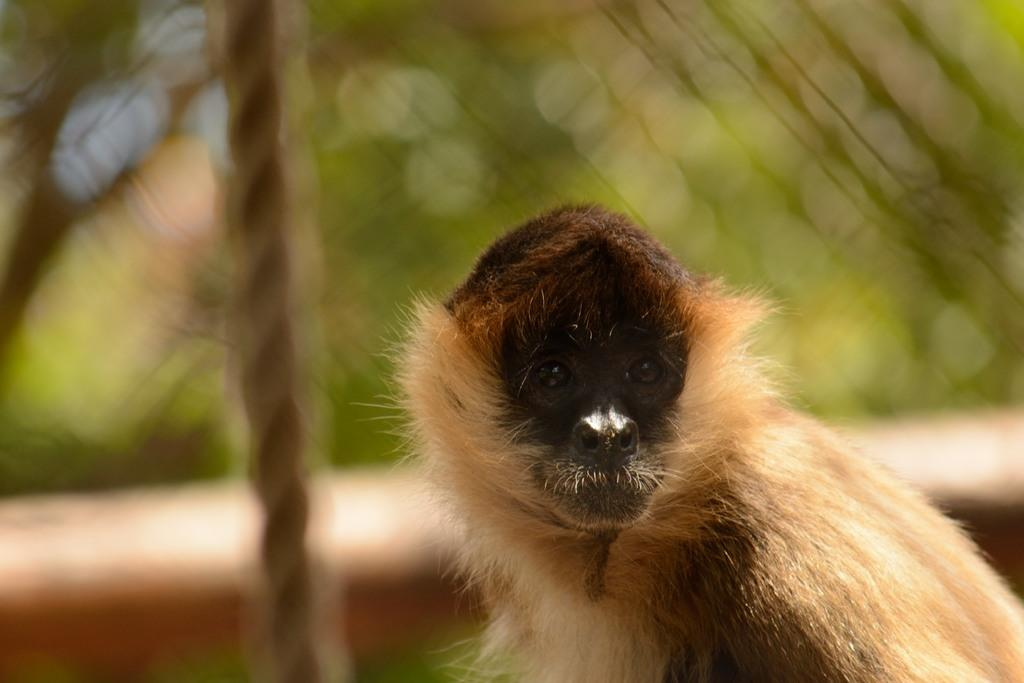What type of animal is in the picture? There is a spider monkey in the picture. What object is present in the picture alongside the spider monkey? There is a rope in the picture. How would you describe the background of the picture? The background of the picture is blurred. How many donkeys can be seen interacting with the spider monkey in the picture? There are no donkeys present in the image. What level of difficulty does the rope present for the spider monkey in the picture? The facts provided do not give any information about the difficulty level of the rope for the spider monkey. --- Facts: 1. There is a person holding a camera in the image. 2. The person is wearing a hat. 3. The background of the image is a cityscape. Absurd Topics: elephant, ocean, bicycle Conversation: What is the person in the image doing? The person in the image is holding a camera. What accessory is the person wearing in the image? The person is wearing a hat. What can be seen in the background of the image? The background of the image is a cityscape. Reasoning: Let's think step by step in order to produce the conversation. We start by identifying the main subject in the image, which is the person holding a camera. Then, we expand the conversation to include other items that are also visible, such as the hat. Finally, we describe the background of the picture, which is a cityscape. Each question is designed to elicit a specific detail about the image that is known from the provided facts. Absurd Question/Answer: Can you see any elephants in the cityscape background of the image? No, there are no elephants present in the image. Is the person riding a bicycle in the image? No, the person is not riding a bicycle in the image; they are holding a camera. 